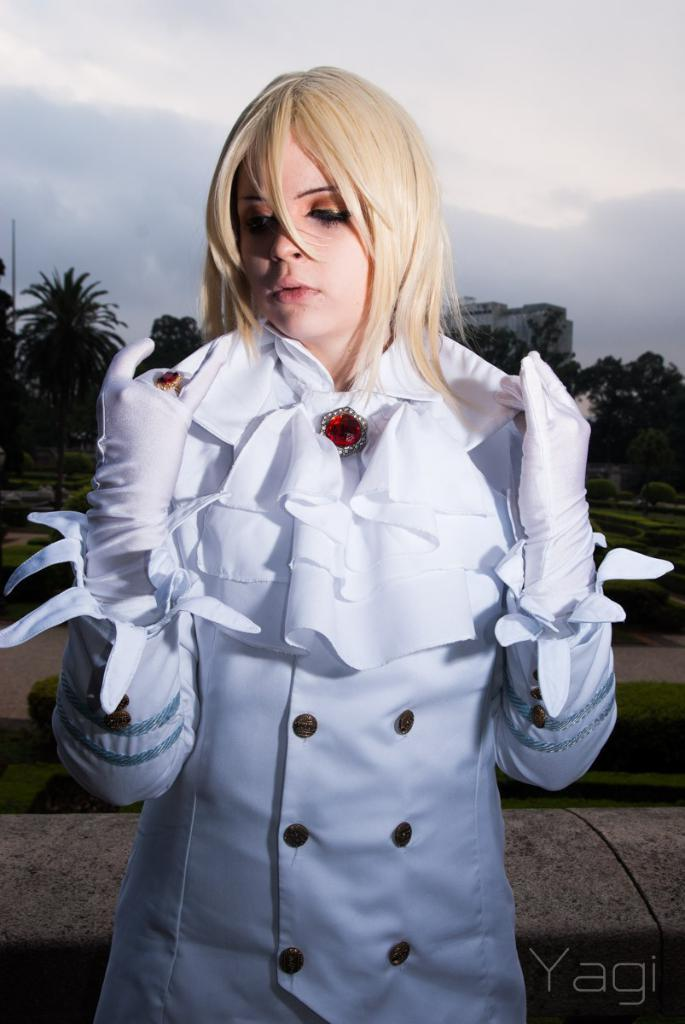Who is the main subject in the image? There is a girl in the image. What is the girl doing in the image? The girl is standing. What is the girl wearing in the image? The girl is wearing a white dress. What can be seen in the background of the image? There are trees visible behind the girl. What type of thread is being used to create harmony in the image? There is no thread or concept of harmony present in the image; it simply features a girl standing in front of trees. 